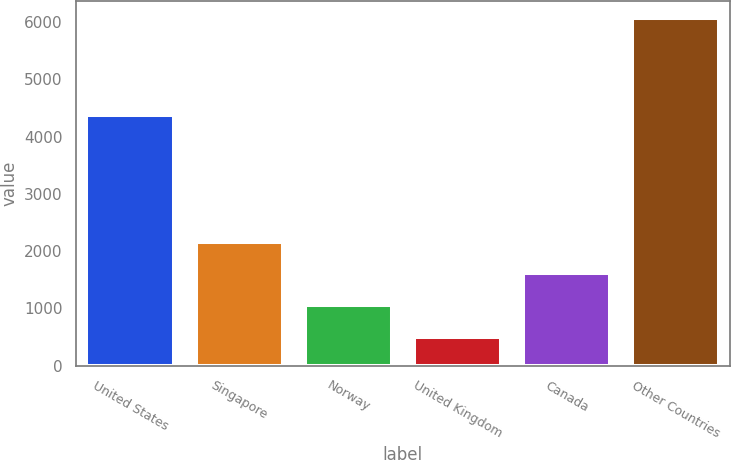Convert chart to OTSL. <chart><loc_0><loc_0><loc_500><loc_500><bar_chart><fcel>United States<fcel>Singapore<fcel>Norway<fcel>United Kingdom<fcel>Canada<fcel>Other Countries<nl><fcel>4369<fcel>2167.1<fcel>1053.7<fcel>497<fcel>1610.4<fcel>6064<nl></chart> 